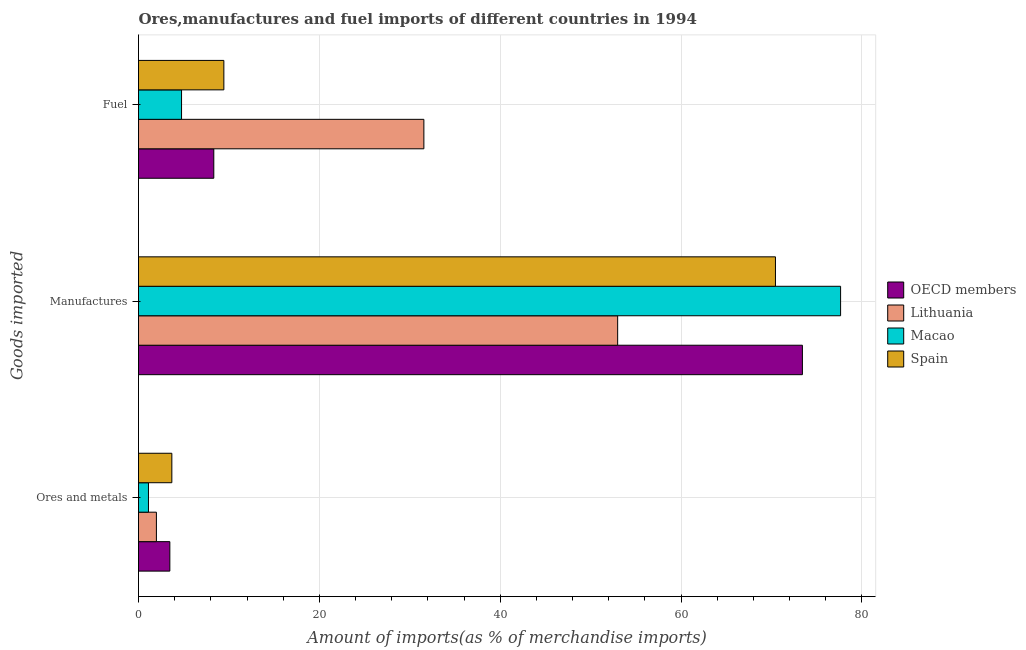How many groups of bars are there?
Provide a short and direct response. 3. How many bars are there on the 2nd tick from the bottom?
Give a very brief answer. 4. What is the label of the 2nd group of bars from the top?
Give a very brief answer. Manufactures. What is the percentage of ores and metals imports in Macao?
Provide a short and direct response. 1.1. Across all countries, what is the maximum percentage of fuel imports?
Make the answer very short. 31.56. Across all countries, what is the minimum percentage of ores and metals imports?
Make the answer very short. 1.1. In which country was the percentage of ores and metals imports maximum?
Make the answer very short. Spain. In which country was the percentage of fuel imports minimum?
Keep it short and to the point. Macao. What is the total percentage of ores and metals imports in the graph?
Offer a very short reply. 10.23. What is the difference between the percentage of manufactures imports in OECD members and that in Spain?
Your response must be concise. 2.98. What is the difference between the percentage of manufactures imports in OECD members and the percentage of fuel imports in Macao?
Your answer should be very brief. 68.65. What is the average percentage of fuel imports per country?
Ensure brevity in your answer.  13.52. What is the difference between the percentage of fuel imports and percentage of ores and metals imports in OECD members?
Ensure brevity in your answer.  4.86. What is the ratio of the percentage of fuel imports in Spain to that in OECD members?
Your response must be concise. 1.13. Is the percentage of ores and metals imports in Lithuania less than that in OECD members?
Keep it short and to the point. Yes. What is the difference between the highest and the second highest percentage of manufactures imports?
Make the answer very short. 4.22. What is the difference between the highest and the lowest percentage of ores and metals imports?
Offer a terse response. 2.59. What does the 3rd bar from the top in Fuel represents?
Your answer should be very brief. Lithuania. What does the 3rd bar from the bottom in Manufactures represents?
Provide a short and direct response. Macao. Is it the case that in every country, the sum of the percentage of ores and metals imports and percentage of manufactures imports is greater than the percentage of fuel imports?
Give a very brief answer. Yes. How many bars are there?
Ensure brevity in your answer.  12. Are all the bars in the graph horizontal?
Provide a short and direct response. Yes. How many countries are there in the graph?
Ensure brevity in your answer.  4. Does the graph contain grids?
Ensure brevity in your answer.  Yes. What is the title of the graph?
Provide a short and direct response. Ores,manufactures and fuel imports of different countries in 1994. Does "Lao PDR" appear as one of the legend labels in the graph?
Your response must be concise. No. What is the label or title of the X-axis?
Offer a very short reply. Amount of imports(as % of merchandise imports). What is the label or title of the Y-axis?
Provide a short and direct response. Goods imported. What is the Amount of imports(as % of merchandise imports) in OECD members in Ores and metals?
Your answer should be very brief. 3.46. What is the Amount of imports(as % of merchandise imports) in Lithuania in Ores and metals?
Your response must be concise. 1.98. What is the Amount of imports(as % of merchandise imports) in Macao in Ores and metals?
Keep it short and to the point. 1.1. What is the Amount of imports(as % of merchandise imports) in Spain in Ores and metals?
Your answer should be very brief. 3.69. What is the Amount of imports(as % of merchandise imports) of OECD members in Manufactures?
Offer a very short reply. 73.41. What is the Amount of imports(as % of merchandise imports) in Lithuania in Manufactures?
Your response must be concise. 52.98. What is the Amount of imports(as % of merchandise imports) of Macao in Manufactures?
Your answer should be very brief. 77.64. What is the Amount of imports(as % of merchandise imports) in Spain in Manufactures?
Provide a short and direct response. 70.43. What is the Amount of imports(as % of merchandise imports) of OECD members in Fuel?
Your answer should be very brief. 8.33. What is the Amount of imports(as % of merchandise imports) of Lithuania in Fuel?
Your response must be concise. 31.56. What is the Amount of imports(as % of merchandise imports) in Macao in Fuel?
Your answer should be very brief. 4.76. What is the Amount of imports(as % of merchandise imports) of Spain in Fuel?
Keep it short and to the point. 9.44. Across all Goods imported, what is the maximum Amount of imports(as % of merchandise imports) of OECD members?
Give a very brief answer. 73.41. Across all Goods imported, what is the maximum Amount of imports(as % of merchandise imports) in Lithuania?
Keep it short and to the point. 52.98. Across all Goods imported, what is the maximum Amount of imports(as % of merchandise imports) in Macao?
Provide a short and direct response. 77.64. Across all Goods imported, what is the maximum Amount of imports(as % of merchandise imports) in Spain?
Offer a very short reply. 70.43. Across all Goods imported, what is the minimum Amount of imports(as % of merchandise imports) in OECD members?
Make the answer very short. 3.46. Across all Goods imported, what is the minimum Amount of imports(as % of merchandise imports) of Lithuania?
Provide a short and direct response. 1.98. Across all Goods imported, what is the minimum Amount of imports(as % of merchandise imports) in Macao?
Ensure brevity in your answer.  1.1. Across all Goods imported, what is the minimum Amount of imports(as % of merchandise imports) of Spain?
Your response must be concise. 3.69. What is the total Amount of imports(as % of merchandise imports) of OECD members in the graph?
Offer a very short reply. 85.2. What is the total Amount of imports(as % of merchandise imports) of Lithuania in the graph?
Keep it short and to the point. 86.52. What is the total Amount of imports(as % of merchandise imports) of Macao in the graph?
Your response must be concise. 83.5. What is the total Amount of imports(as % of merchandise imports) of Spain in the graph?
Make the answer very short. 83.56. What is the difference between the Amount of imports(as % of merchandise imports) of OECD members in Ores and metals and that in Manufactures?
Your response must be concise. -69.95. What is the difference between the Amount of imports(as % of merchandise imports) of Lithuania in Ores and metals and that in Manufactures?
Give a very brief answer. -51. What is the difference between the Amount of imports(as % of merchandise imports) of Macao in Ores and metals and that in Manufactures?
Your response must be concise. -76.54. What is the difference between the Amount of imports(as % of merchandise imports) in Spain in Ores and metals and that in Manufactures?
Your answer should be very brief. -66.75. What is the difference between the Amount of imports(as % of merchandise imports) in OECD members in Ores and metals and that in Fuel?
Your response must be concise. -4.86. What is the difference between the Amount of imports(as % of merchandise imports) of Lithuania in Ores and metals and that in Fuel?
Your response must be concise. -29.58. What is the difference between the Amount of imports(as % of merchandise imports) in Macao in Ores and metals and that in Fuel?
Offer a very short reply. -3.66. What is the difference between the Amount of imports(as % of merchandise imports) of Spain in Ores and metals and that in Fuel?
Offer a terse response. -5.75. What is the difference between the Amount of imports(as % of merchandise imports) in OECD members in Manufactures and that in Fuel?
Offer a very short reply. 65.09. What is the difference between the Amount of imports(as % of merchandise imports) in Lithuania in Manufactures and that in Fuel?
Provide a short and direct response. 21.43. What is the difference between the Amount of imports(as % of merchandise imports) of Macao in Manufactures and that in Fuel?
Offer a terse response. 72.88. What is the difference between the Amount of imports(as % of merchandise imports) of Spain in Manufactures and that in Fuel?
Offer a terse response. 61. What is the difference between the Amount of imports(as % of merchandise imports) of OECD members in Ores and metals and the Amount of imports(as % of merchandise imports) of Lithuania in Manufactures?
Your answer should be compact. -49.52. What is the difference between the Amount of imports(as % of merchandise imports) of OECD members in Ores and metals and the Amount of imports(as % of merchandise imports) of Macao in Manufactures?
Offer a terse response. -74.17. What is the difference between the Amount of imports(as % of merchandise imports) in OECD members in Ores and metals and the Amount of imports(as % of merchandise imports) in Spain in Manufactures?
Make the answer very short. -66.97. What is the difference between the Amount of imports(as % of merchandise imports) of Lithuania in Ores and metals and the Amount of imports(as % of merchandise imports) of Macao in Manufactures?
Provide a short and direct response. -75.66. What is the difference between the Amount of imports(as % of merchandise imports) in Lithuania in Ores and metals and the Amount of imports(as % of merchandise imports) in Spain in Manufactures?
Your answer should be compact. -68.45. What is the difference between the Amount of imports(as % of merchandise imports) in Macao in Ores and metals and the Amount of imports(as % of merchandise imports) in Spain in Manufactures?
Make the answer very short. -69.33. What is the difference between the Amount of imports(as % of merchandise imports) in OECD members in Ores and metals and the Amount of imports(as % of merchandise imports) in Lithuania in Fuel?
Your response must be concise. -28.09. What is the difference between the Amount of imports(as % of merchandise imports) in OECD members in Ores and metals and the Amount of imports(as % of merchandise imports) in Macao in Fuel?
Your answer should be very brief. -1.29. What is the difference between the Amount of imports(as % of merchandise imports) in OECD members in Ores and metals and the Amount of imports(as % of merchandise imports) in Spain in Fuel?
Make the answer very short. -5.97. What is the difference between the Amount of imports(as % of merchandise imports) of Lithuania in Ores and metals and the Amount of imports(as % of merchandise imports) of Macao in Fuel?
Make the answer very short. -2.78. What is the difference between the Amount of imports(as % of merchandise imports) in Lithuania in Ores and metals and the Amount of imports(as % of merchandise imports) in Spain in Fuel?
Your answer should be compact. -7.46. What is the difference between the Amount of imports(as % of merchandise imports) in Macao in Ores and metals and the Amount of imports(as % of merchandise imports) in Spain in Fuel?
Provide a succinct answer. -8.34. What is the difference between the Amount of imports(as % of merchandise imports) of OECD members in Manufactures and the Amount of imports(as % of merchandise imports) of Lithuania in Fuel?
Offer a very short reply. 41.86. What is the difference between the Amount of imports(as % of merchandise imports) of OECD members in Manufactures and the Amount of imports(as % of merchandise imports) of Macao in Fuel?
Your answer should be compact. 68.66. What is the difference between the Amount of imports(as % of merchandise imports) of OECD members in Manufactures and the Amount of imports(as % of merchandise imports) of Spain in Fuel?
Offer a terse response. 63.98. What is the difference between the Amount of imports(as % of merchandise imports) in Lithuania in Manufactures and the Amount of imports(as % of merchandise imports) in Macao in Fuel?
Your response must be concise. 48.22. What is the difference between the Amount of imports(as % of merchandise imports) in Lithuania in Manufactures and the Amount of imports(as % of merchandise imports) in Spain in Fuel?
Your answer should be very brief. 43.55. What is the difference between the Amount of imports(as % of merchandise imports) of Macao in Manufactures and the Amount of imports(as % of merchandise imports) of Spain in Fuel?
Offer a terse response. 68.2. What is the average Amount of imports(as % of merchandise imports) of OECD members per Goods imported?
Ensure brevity in your answer.  28.4. What is the average Amount of imports(as % of merchandise imports) of Lithuania per Goods imported?
Keep it short and to the point. 28.84. What is the average Amount of imports(as % of merchandise imports) in Macao per Goods imported?
Offer a very short reply. 27.83. What is the average Amount of imports(as % of merchandise imports) in Spain per Goods imported?
Offer a very short reply. 27.85. What is the difference between the Amount of imports(as % of merchandise imports) of OECD members and Amount of imports(as % of merchandise imports) of Lithuania in Ores and metals?
Your answer should be compact. 1.48. What is the difference between the Amount of imports(as % of merchandise imports) in OECD members and Amount of imports(as % of merchandise imports) in Macao in Ores and metals?
Offer a very short reply. 2.36. What is the difference between the Amount of imports(as % of merchandise imports) in OECD members and Amount of imports(as % of merchandise imports) in Spain in Ores and metals?
Your answer should be compact. -0.22. What is the difference between the Amount of imports(as % of merchandise imports) in Lithuania and Amount of imports(as % of merchandise imports) in Macao in Ores and metals?
Ensure brevity in your answer.  0.88. What is the difference between the Amount of imports(as % of merchandise imports) in Lithuania and Amount of imports(as % of merchandise imports) in Spain in Ores and metals?
Ensure brevity in your answer.  -1.71. What is the difference between the Amount of imports(as % of merchandise imports) of Macao and Amount of imports(as % of merchandise imports) of Spain in Ores and metals?
Your response must be concise. -2.59. What is the difference between the Amount of imports(as % of merchandise imports) in OECD members and Amount of imports(as % of merchandise imports) in Lithuania in Manufactures?
Your response must be concise. 20.43. What is the difference between the Amount of imports(as % of merchandise imports) of OECD members and Amount of imports(as % of merchandise imports) of Macao in Manufactures?
Provide a succinct answer. -4.22. What is the difference between the Amount of imports(as % of merchandise imports) in OECD members and Amount of imports(as % of merchandise imports) in Spain in Manufactures?
Give a very brief answer. 2.98. What is the difference between the Amount of imports(as % of merchandise imports) of Lithuania and Amount of imports(as % of merchandise imports) of Macao in Manufactures?
Provide a short and direct response. -24.65. What is the difference between the Amount of imports(as % of merchandise imports) in Lithuania and Amount of imports(as % of merchandise imports) in Spain in Manufactures?
Your response must be concise. -17.45. What is the difference between the Amount of imports(as % of merchandise imports) of Macao and Amount of imports(as % of merchandise imports) of Spain in Manufactures?
Offer a terse response. 7.2. What is the difference between the Amount of imports(as % of merchandise imports) of OECD members and Amount of imports(as % of merchandise imports) of Lithuania in Fuel?
Make the answer very short. -23.23. What is the difference between the Amount of imports(as % of merchandise imports) of OECD members and Amount of imports(as % of merchandise imports) of Macao in Fuel?
Your answer should be very brief. 3.57. What is the difference between the Amount of imports(as % of merchandise imports) in OECD members and Amount of imports(as % of merchandise imports) in Spain in Fuel?
Keep it short and to the point. -1.11. What is the difference between the Amount of imports(as % of merchandise imports) of Lithuania and Amount of imports(as % of merchandise imports) of Macao in Fuel?
Your response must be concise. 26.8. What is the difference between the Amount of imports(as % of merchandise imports) in Lithuania and Amount of imports(as % of merchandise imports) in Spain in Fuel?
Make the answer very short. 22.12. What is the difference between the Amount of imports(as % of merchandise imports) of Macao and Amount of imports(as % of merchandise imports) of Spain in Fuel?
Make the answer very short. -4.68. What is the ratio of the Amount of imports(as % of merchandise imports) of OECD members in Ores and metals to that in Manufactures?
Your answer should be very brief. 0.05. What is the ratio of the Amount of imports(as % of merchandise imports) of Lithuania in Ores and metals to that in Manufactures?
Provide a succinct answer. 0.04. What is the ratio of the Amount of imports(as % of merchandise imports) in Macao in Ores and metals to that in Manufactures?
Offer a very short reply. 0.01. What is the ratio of the Amount of imports(as % of merchandise imports) in Spain in Ores and metals to that in Manufactures?
Provide a succinct answer. 0.05. What is the ratio of the Amount of imports(as % of merchandise imports) in OECD members in Ores and metals to that in Fuel?
Your answer should be very brief. 0.42. What is the ratio of the Amount of imports(as % of merchandise imports) in Lithuania in Ores and metals to that in Fuel?
Make the answer very short. 0.06. What is the ratio of the Amount of imports(as % of merchandise imports) of Macao in Ores and metals to that in Fuel?
Give a very brief answer. 0.23. What is the ratio of the Amount of imports(as % of merchandise imports) of Spain in Ores and metals to that in Fuel?
Your answer should be very brief. 0.39. What is the ratio of the Amount of imports(as % of merchandise imports) in OECD members in Manufactures to that in Fuel?
Your answer should be very brief. 8.82. What is the ratio of the Amount of imports(as % of merchandise imports) in Lithuania in Manufactures to that in Fuel?
Offer a very short reply. 1.68. What is the ratio of the Amount of imports(as % of merchandise imports) in Macao in Manufactures to that in Fuel?
Offer a very short reply. 16.31. What is the ratio of the Amount of imports(as % of merchandise imports) in Spain in Manufactures to that in Fuel?
Give a very brief answer. 7.46. What is the difference between the highest and the second highest Amount of imports(as % of merchandise imports) of OECD members?
Offer a very short reply. 65.09. What is the difference between the highest and the second highest Amount of imports(as % of merchandise imports) in Lithuania?
Your answer should be compact. 21.43. What is the difference between the highest and the second highest Amount of imports(as % of merchandise imports) of Macao?
Offer a terse response. 72.88. What is the difference between the highest and the second highest Amount of imports(as % of merchandise imports) of Spain?
Your answer should be very brief. 61. What is the difference between the highest and the lowest Amount of imports(as % of merchandise imports) of OECD members?
Your answer should be very brief. 69.95. What is the difference between the highest and the lowest Amount of imports(as % of merchandise imports) in Lithuania?
Provide a short and direct response. 51. What is the difference between the highest and the lowest Amount of imports(as % of merchandise imports) in Macao?
Offer a very short reply. 76.54. What is the difference between the highest and the lowest Amount of imports(as % of merchandise imports) of Spain?
Offer a terse response. 66.75. 